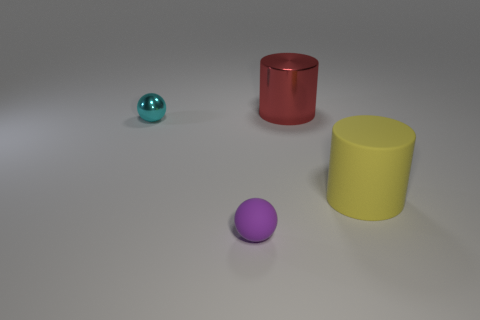What could be the purpose of this arrangement? This arrangement appears to be a simplistic and controlled setup, possibly designed for a visual exercise or a study in object recognition. It could be used to demonstrate principles of color, shape, or lighting in a minimalistic fashion. 